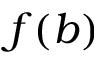<formula> <loc_0><loc_0><loc_500><loc_500>f ( b )</formula> 